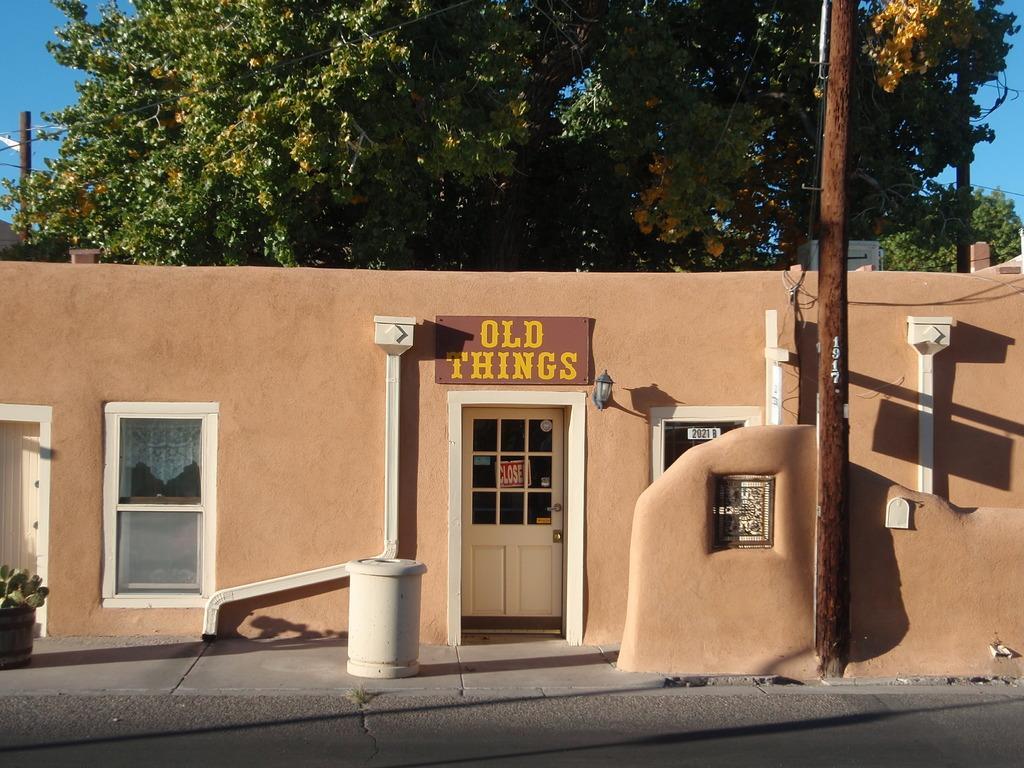In one or two sentences, can you explain what this image depicts? In this picture we can see the road, door, house plant, name boards, windows, walls, poles, trees, some objects and in the background we can see the sky. 